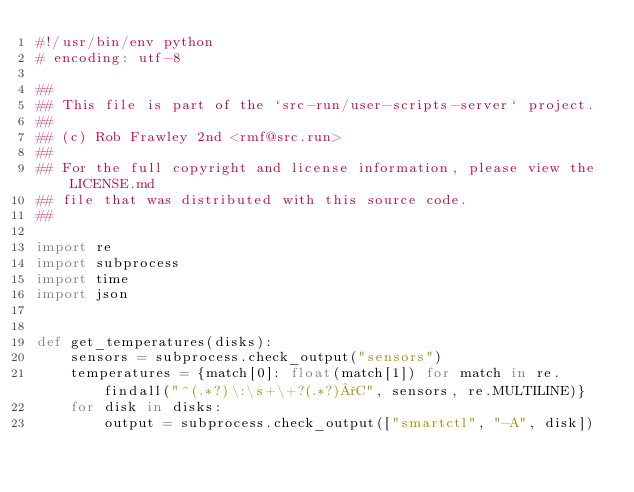Convert code to text. <code><loc_0><loc_0><loc_500><loc_500><_Python_>#!/usr/bin/env python
# encoding: utf-8

##
## This file is part of the `src-run/user-scripts-server` project.
##
## (c) Rob Frawley 2nd <rmf@src.run>
##
## For the full copyright and license information, please view the LICENSE.md
## file that was distributed with this source code.
##

import re
import subprocess
import time
import json


def get_temperatures(disks):
    sensors = subprocess.check_output("sensors")
    temperatures = {match[0]: float(match[1]) for match in re.findall("^(.*?)\:\s+\+?(.*?)°C", sensors, re.MULTILINE)}
    for disk in disks:
        output = subprocess.check_output(["smartctl", "-A", disk])</code> 